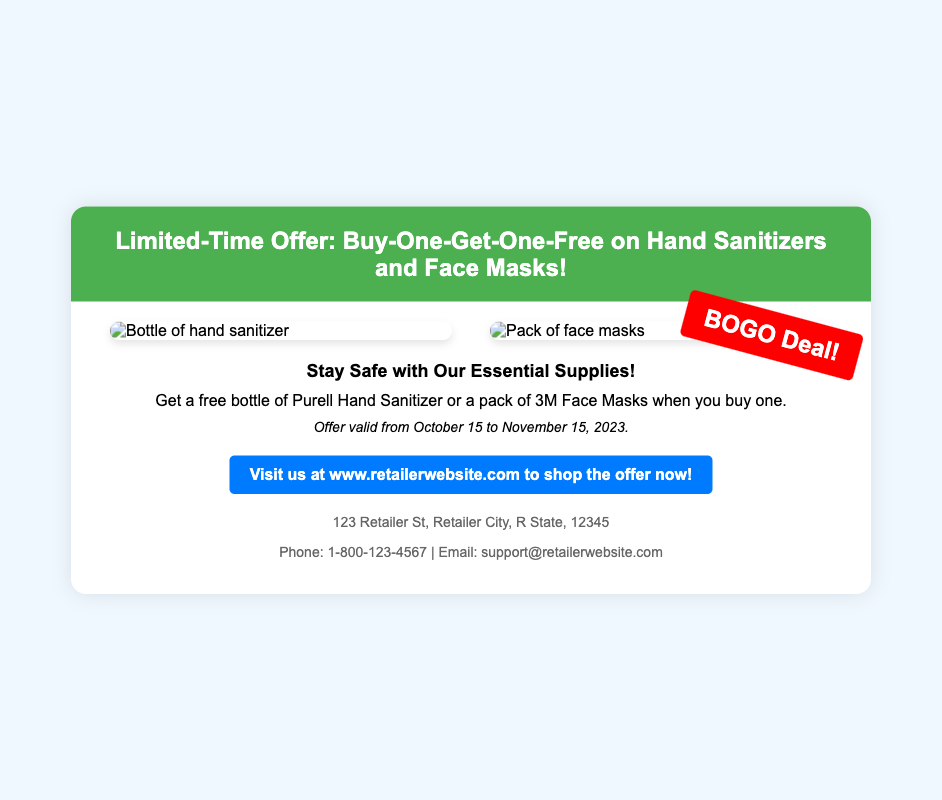What is the offer being advertised? The offer is for a Buy-One-Get-One-Free deal on hand sanitizers and face masks.
Answer: Buy-One-Get-One-Free When is the offer valid? The offer is valid from October 15 to November 15, 2023.
Answer: October 15 to November 15, 2023 What type of sanitizer is included in the deal? The document specifies Purell Hand Sanitizer as included in the deal.
Answer: Purell What is the image of the second product? The second product shown in the advertisement is a pack of face masks.
Answer: Pack of face masks What promotional phrase is used in the overlay? The overlay features the promotional phrase “BOGO Deal!”
Answer: BOGO Deal! Where can customers shop the offer? Customers can visit the retailer's website to shop the offer.
Answer: www.retailerwebsite.com What is the phone number provided for contact? The document includes a contact phone number for customer inquiries.
Answer: 1-800-123-4567 What color is the header background? The color of the header background in the advertisement is green.
Answer: Green What style of fonts is used in the advertisement? The advertisement uses the Arial font family.
Answer: Arial 